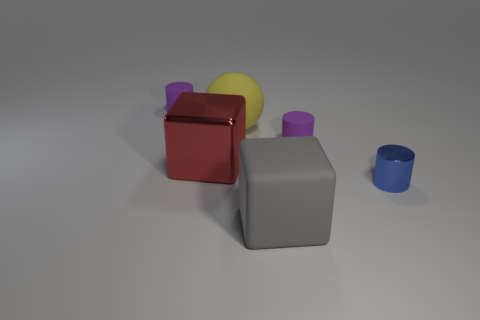Subtract all small metal cylinders. How many cylinders are left? 2 Subtract all blue cylinders. How many cylinders are left? 2 Add 4 small shiny things. How many objects exist? 10 Subtract all gray spheres. How many purple cylinders are left? 2 Subtract all balls. How many objects are left? 5 Subtract 2 cylinders. How many cylinders are left? 1 Subtract all purple cylinders. Subtract all gray cubes. How many cylinders are left? 1 Subtract all big cyan cubes. Subtract all gray matte objects. How many objects are left? 5 Add 6 small purple things. How many small purple things are left? 8 Add 1 gray objects. How many gray objects exist? 2 